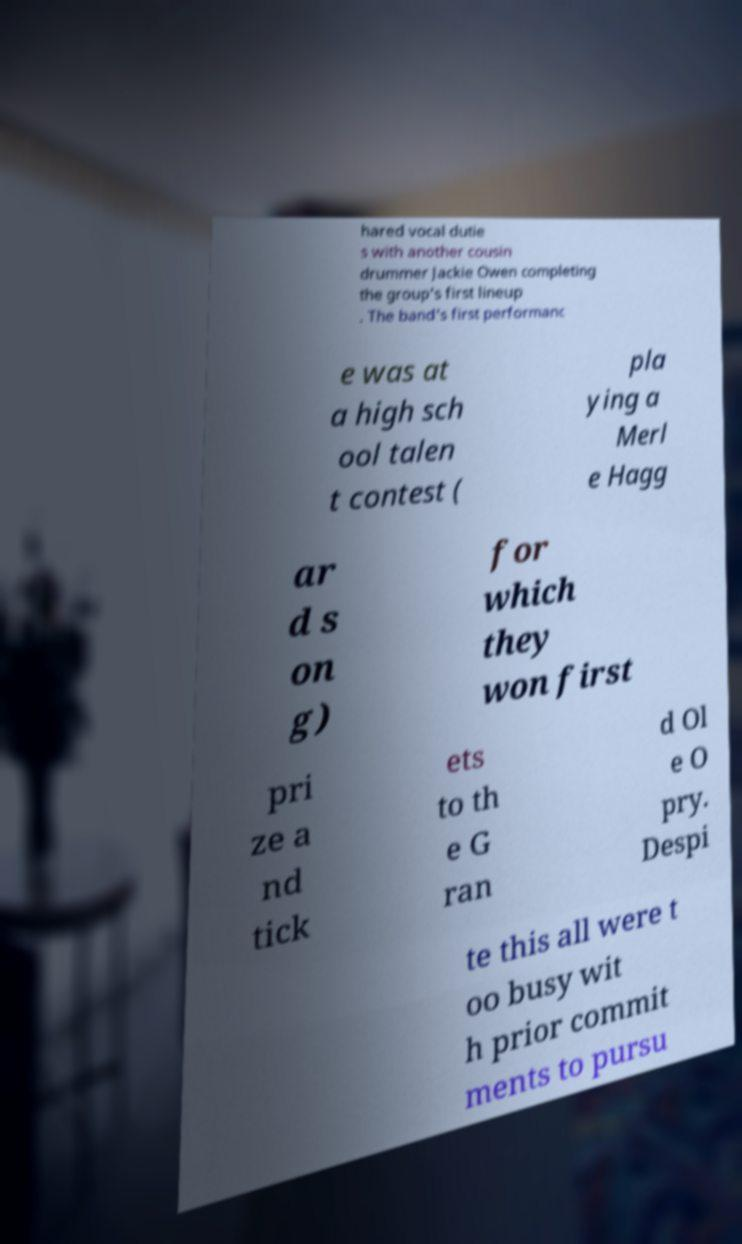Could you extract and type out the text from this image? hared vocal dutie s with another cousin drummer Jackie Owen completing the group's first lineup . The band's first performanc e was at a high sch ool talen t contest ( pla ying a Merl e Hagg ar d s on g) for which they won first pri ze a nd tick ets to th e G ran d Ol e O pry. Despi te this all were t oo busy wit h prior commit ments to pursu 